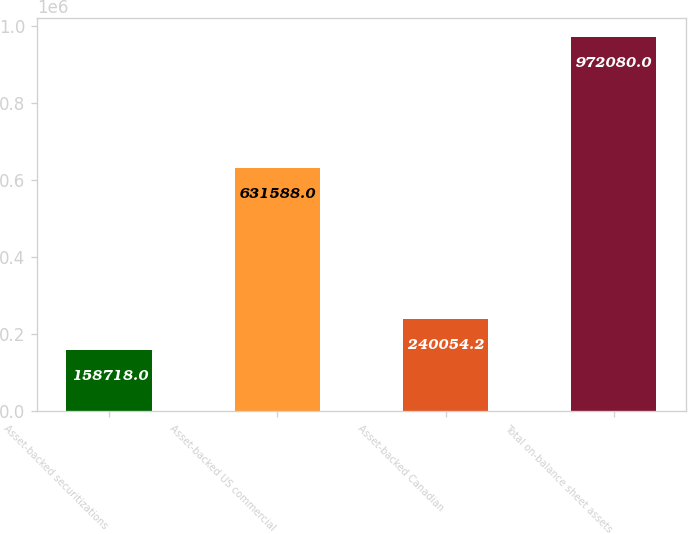<chart> <loc_0><loc_0><loc_500><loc_500><bar_chart><fcel>Asset-backed securitizations<fcel>Asset-backed US commercial<fcel>Asset-backed Canadian<fcel>Total on-balance sheet assets<nl><fcel>158718<fcel>631588<fcel>240054<fcel>972080<nl></chart> 